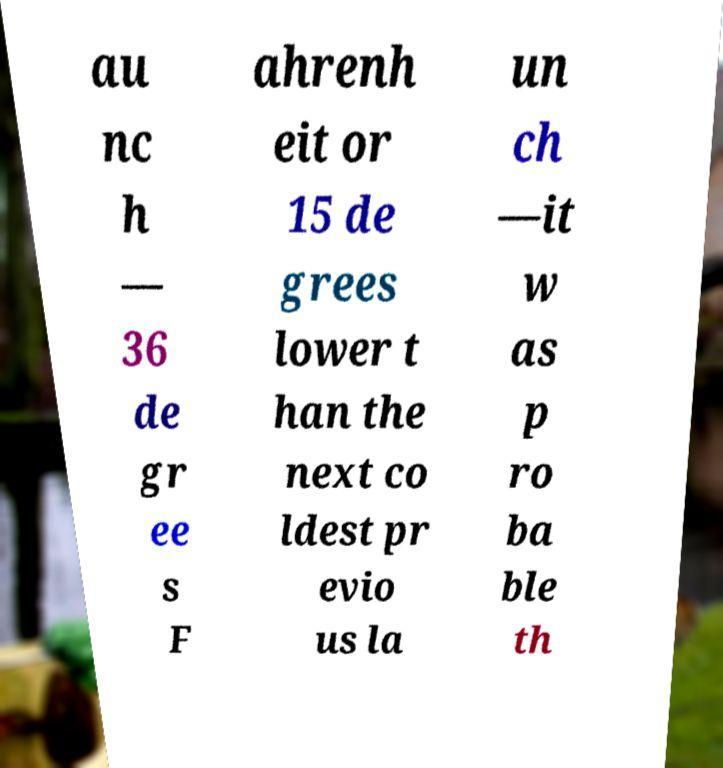I need the written content from this picture converted into text. Can you do that? au nc h — 36 de gr ee s F ahrenh eit or 15 de grees lower t han the next co ldest pr evio us la un ch —it w as p ro ba ble th 